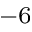Convert formula to latex. <formula><loc_0><loc_0><loc_500><loc_500>^ { - 6 }</formula> 